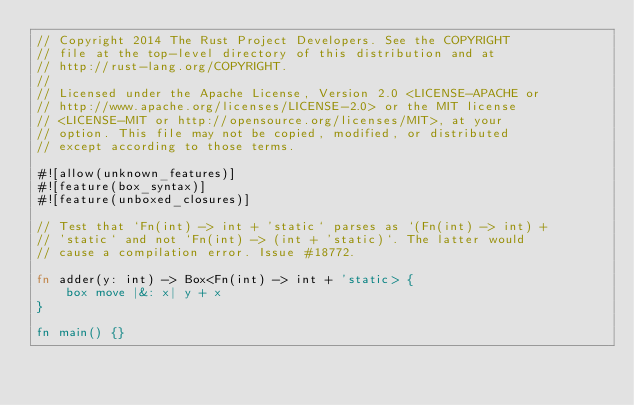Convert code to text. <code><loc_0><loc_0><loc_500><loc_500><_Rust_>// Copyright 2014 The Rust Project Developers. See the COPYRIGHT
// file at the top-level directory of this distribution and at
// http://rust-lang.org/COPYRIGHT.
//
// Licensed under the Apache License, Version 2.0 <LICENSE-APACHE or
// http://www.apache.org/licenses/LICENSE-2.0> or the MIT license
// <LICENSE-MIT or http://opensource.org/licenses/MIT>, at your
// option. This file may not be copied, modified, or distributed
// except according to those terms.

#![allow(unknown_features)]
#![feature(box_syntax)]
#![feature(unboxed_closures)]

// Test that `Fn(int) -> int + 'static` parses as `(Fn(int) -> int) +
// 'static` and not `Fn(int) -> (int + 'static)`. The latter would
// cause a compilation error. Issue #18772.

fn adder(y: int) -> Box<Fn(int) -> int + 'static> {
    box move |&: x| y + x
}

fn main() {}
</code> 